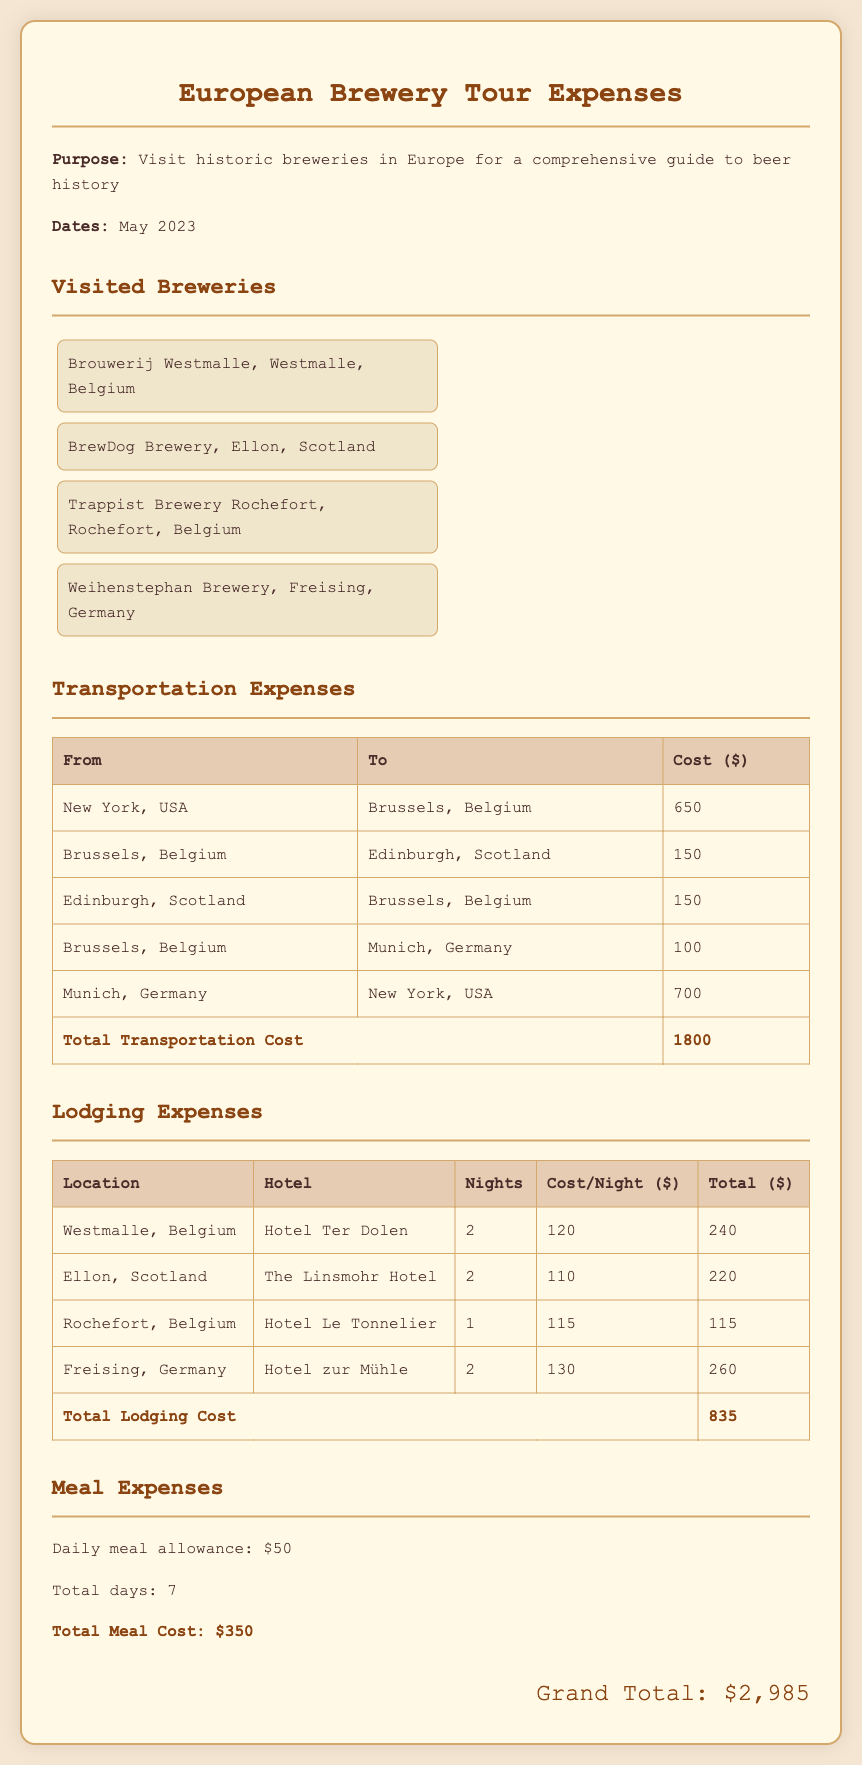What is the total transportation cost? The total transportation cost is clearly listed in the transportation expenses section of the document, which sums to $1800.
Answer: $1800 What are the names of the breweries visited? The names of the breweries can be found in the visited breweries section of the document, listed as Brouwerij Westmalle, BrewDog Brewery, Trappist Brewery Rochefort, and Weihenstephan Brewery.
Answer: Brouwerij Westmalle, BrewDog Brewery, Trappist Brewery Rochefort, Weihenstephan Brewery What is the total meal cost? The total meal cost is specified in the meal expenses section, which totals to $350.
Answer: $350 How many nights were spent in Westmalle, Belgium? The number of nights spent in Westmalle can be found in the lodging expenses section, indicating that 2 nights were spent there.
Answer: 2 What was the daily meal allowance? The daily meal allowance is explicitly stated in the meal expenses section of the document, which is $50.
Answer: $50 What is the grand total of expenses? The grand total can be found at the bottom of the document, aggregating all costs to be $2,985.
Answer: $2,985 How many days did the trip last? The total days are inferred from the meal expenses section since there is a total meal cost for 7 days mentioned.
Answer: 7 Which hotel was used in Freising, Germany? The hotel information can be retrieved from the lodging expenses section, which states that the Hotel zur Mühle was used in Freising, Germany.
Answer: Hotel zur Mühle What is the purpose of the trip? The purpose is stated at the top of the document as a visit to historic breweries in Europe for a comprehensive guide to beer history.
Answer: Visit historic breweries for a comprehensive guide to beer history 